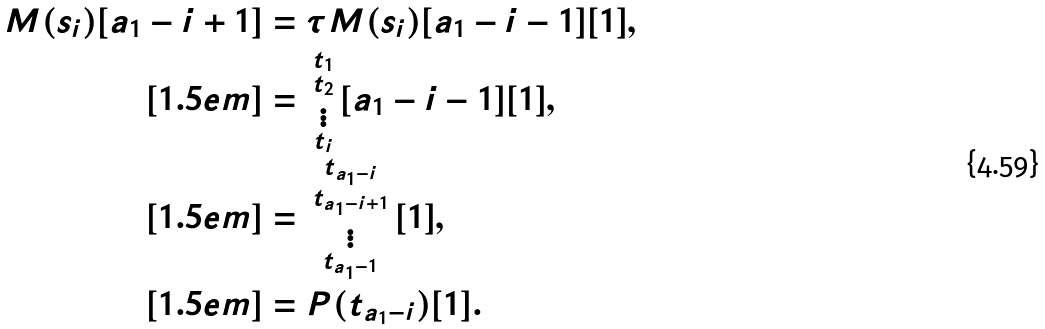<formula> <loc_0><loc_0><loc_500><loc_500>M ( s _ { i } ) [ a _ { 1 } - i + 1 ] & = \tau M ( s _ { i } ) [ a _ { 1 } - i - 1 ] [ 1 ] , \\ [ 1 . 5 e m ] & = \begin{smallmatrix} t _ { 1 } \\ t _ { 2 } \\ \vdots \\ t _ { i } \end{smallmatrix} [ a _ { 1 } - i - 1 ] [ 1 ] , \\ [ 1 . 5 e m ] & = \begin{smallmatrix} t _ { a _ { 1 } - i } \\ t _ { a _ { 1 } - i + 1 } \\ \vdots \\ t _ { a _ { 1 } - 1 } \end{smallmatrix} [ 1 ] , \\ [ 1 . 5 e m ] & = P ( t _ { a _ { 1 } - i } ) [ 1 ] .</formula> 